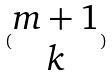<formula> <loc_0><loc_0><loc_500><loc_500>( \begin{matrix} m + 1 \\ k \end{matrix} )</formula> 